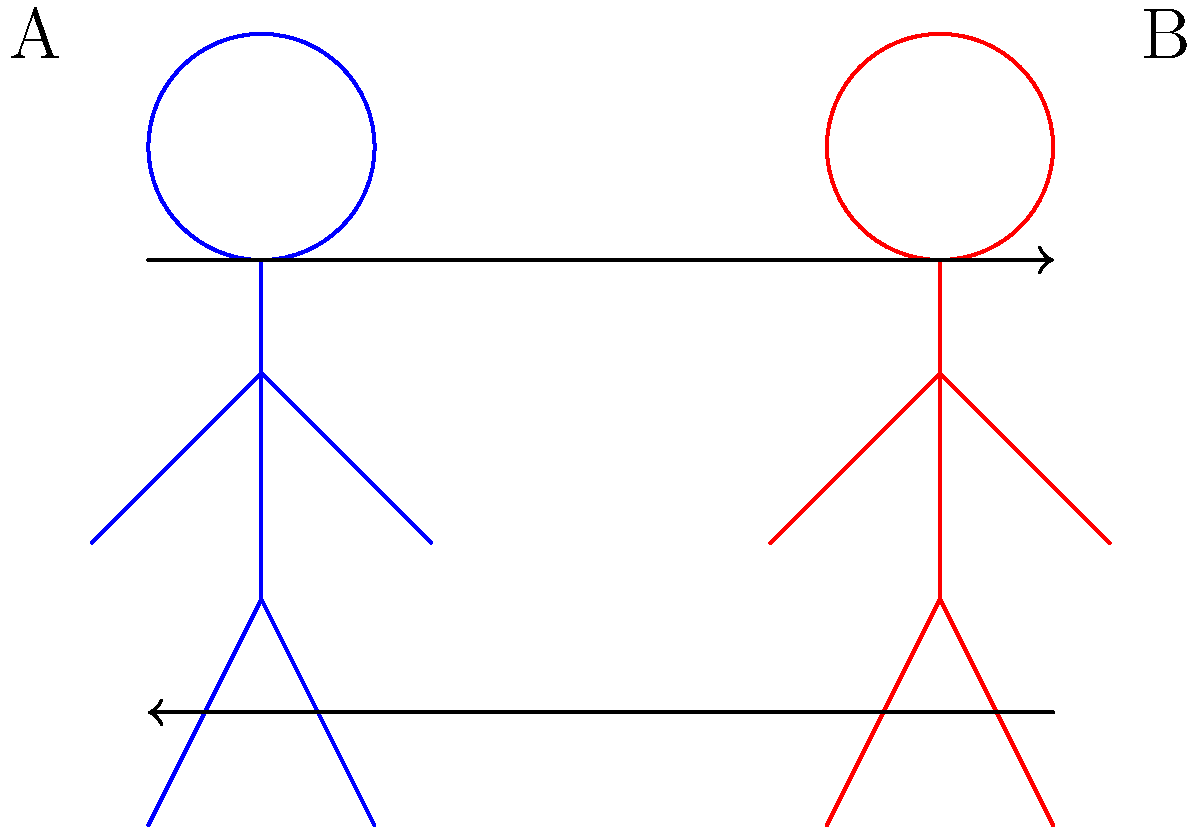In the diagram, two figures are shown with arrows indicating their interaction. As a theater director, how would you interpret this body language to enhance the narrator's storytelling for a pivotal scene where two characters are at odds? 1. Observe the two figures in the diagram, labeled A and B.

2. Note the arrows between the figures:
   - An arrow pointing from A to B at the top
   - An arrow pointing from B to A at the bottom

3. Interpret the body language:
   - The top arrow suggests that figure A is initiating an action or communication towards B.
   - The bottom arrow indicates that figure B is responding or reacting to A.
   - The opposing directions of the arrows imply a back-and-forth exchange or conflict.

4. Apply this to storytelling:
   - This diagram represents a dynamic interaction between two characters.
   - It suggests a scene with tension, disagreement, or a power struggle.
   - The narrator should emphasize the give-and-take nature of the interaction.

5. Enhance the narration:
   - Use voice modulation to distinguish between the characters' actions and reactions.
   - Employ pacing to build tension, slowing down at crucial moments of exchange.
   - Incorporate pauses to allow the audience to absorb the weight of each character's actions.

6. Body language cues for the narrator:
   - Use hand gestures mimicking the arrows to physically represent the exchange.
   - Shift body position slightly when switching between characters to visually represent the back-and-forth.

7. Emotional undertones:
   - Infuse the narration with subtle emotional cues that reflect the conflict.
   - Use tone to convey the intensity of the exchange without overpowering the actual dialogue.
Answer: Emphasize dynamic tension through voice modulation, pacing, and subtle gestures to convey a conflicting exchange between characters. 